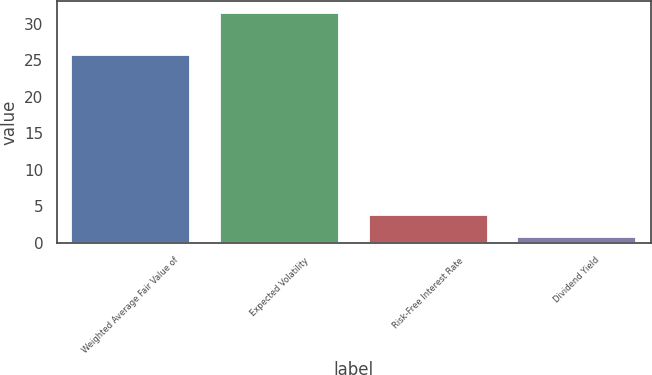<chart> <loc_0><loc_0><loc_500><loc_500><bar_chart><fcel>Weighted Average Fair Value of<fcel>Expected Volatility<fcel>Risk-Free Interest Rate<fcel>Dividend Yield<nl><fcel>25.78<fcel>31.54<fcel>3.84<fcel>0.76<nl></chart> 